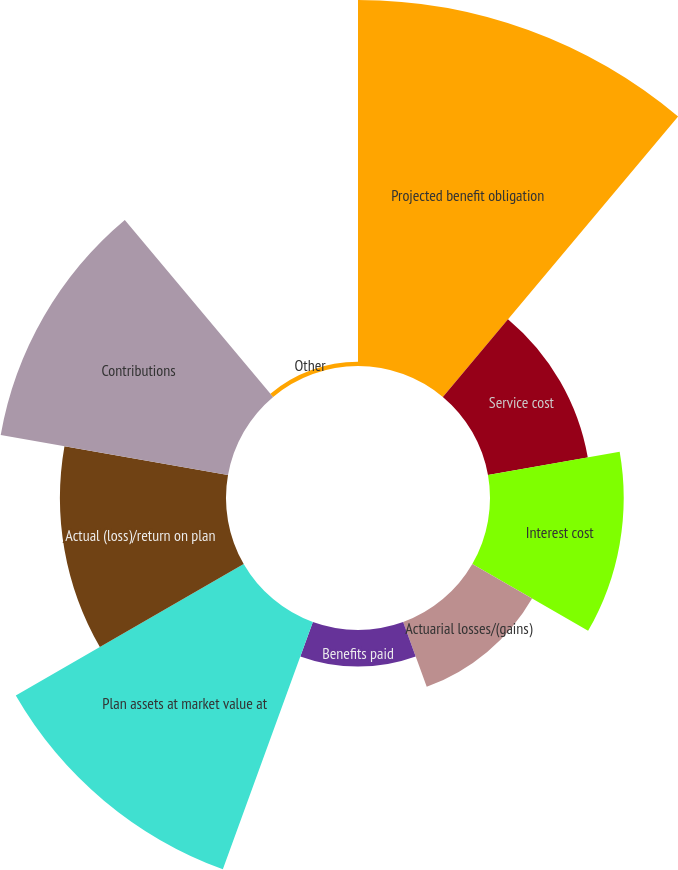Convert chart to OTSL. <chart><loc_0><loc_0><loc_500><loc_500><pie_chart><fcel>Projected benefit obligation<fcel>Service cost<fcel>Interest cost<fcel>Actuarial losses/(gains)<fcel>Benefits paid<fcel>Plan assets at market value at<fcel>Actual (loss)/return on plan<fcel>Contributions<fcel>Other<nl><fcel>26.69%<fcel>7.39%<fcel>9.75%<fcel>5.03%<fcel>2.67%<fcel>19.19%<fcel>12.11%<fcel>16.83%<fcel>0.31%<nl></chart> 